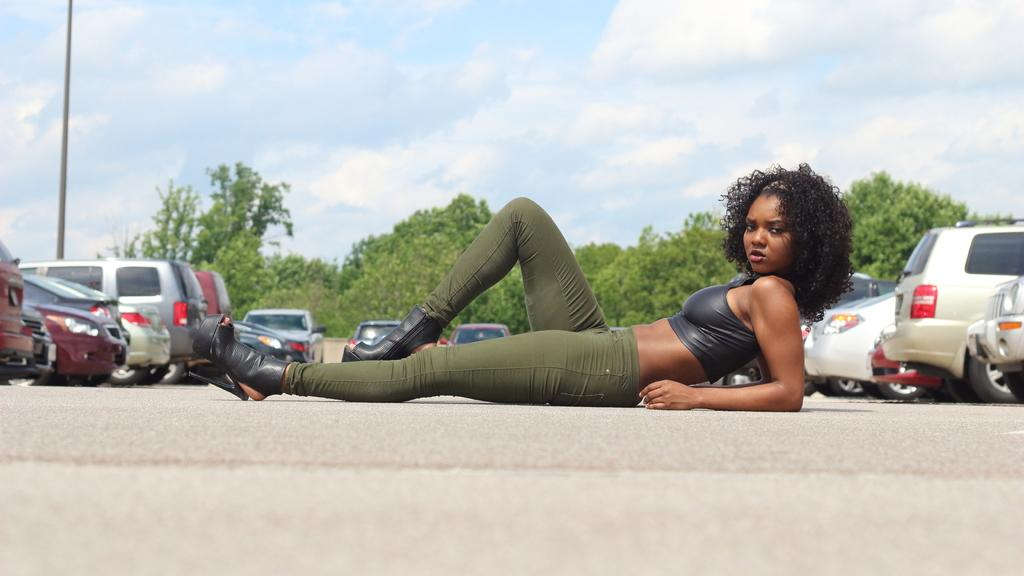What is the main subject of the image? There is a lady laying on the road in the image. What else can be seen around the lady? There are vehicles parked around her. What can be seen in the background of the image? There are trees, a pole, and the sky visible in the background of the image. What type of ink can be seen dripping from the deer in the image? There is no deer present in the image, and therefore no ink can be seen dripping from it. 